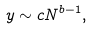<formula> <loc_0><loc_0><loc_500><loc_500>y \sim c N ^ { b - 1 } ,</formula> 